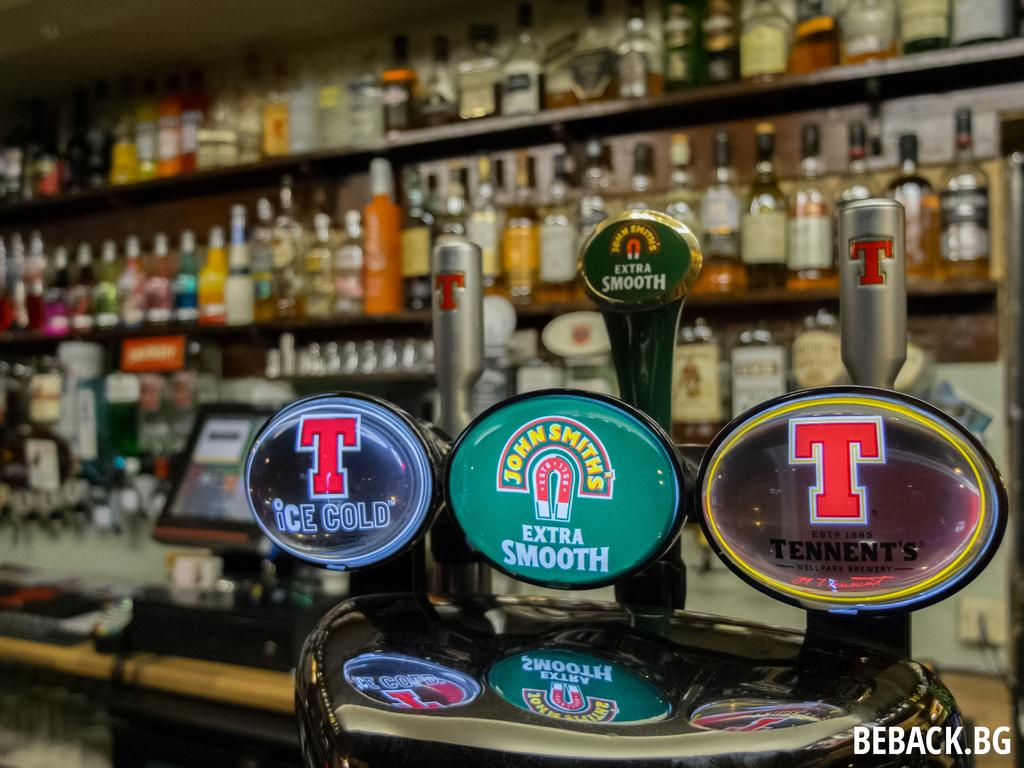<image>
Provide a brief description of the given image. On tap at the bar are the Ice Cold, John Smith's Extra Smooth and Tennent beers. 